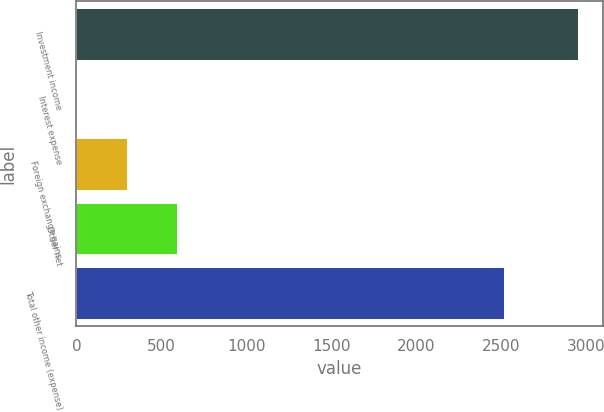Convert chart. <chart><loc_0><loc_0><loc_500><loc_500><bar_chart><fcel>Investment income<fcel>Interest expense<fcel>Foreign exchange gains<fcel>Other net<fcel>Total other income (expense)<nl><fcel>2949<fcel>5<fcel>299.4<fcel>593.8<fcel>2516<nl></chart> 